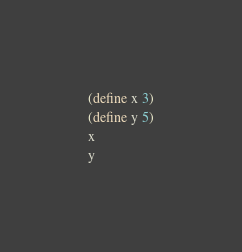<code> <loc_0><loc_0><loc_500><loc_500><_Scheme_>(define x 3)
(define y 5)
x
y
</code> 